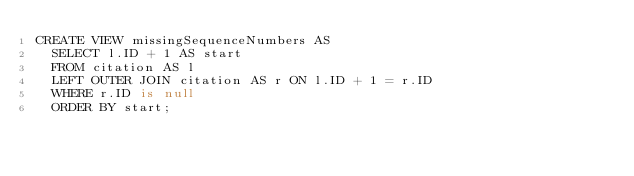<code> <loc_0><loc_0><loc_500><loc_500><_SQL_>CREATE VIEW missingSequenceNumbers AS 
  SELECT l.ID + 1 AS start 
  FROM citation AS l 
  LEFT OUTER JOIN citation AS r ON l.ID + 1 = r.ID 
  WHERE r.ID is null 
  ORDER BY start;</code> 